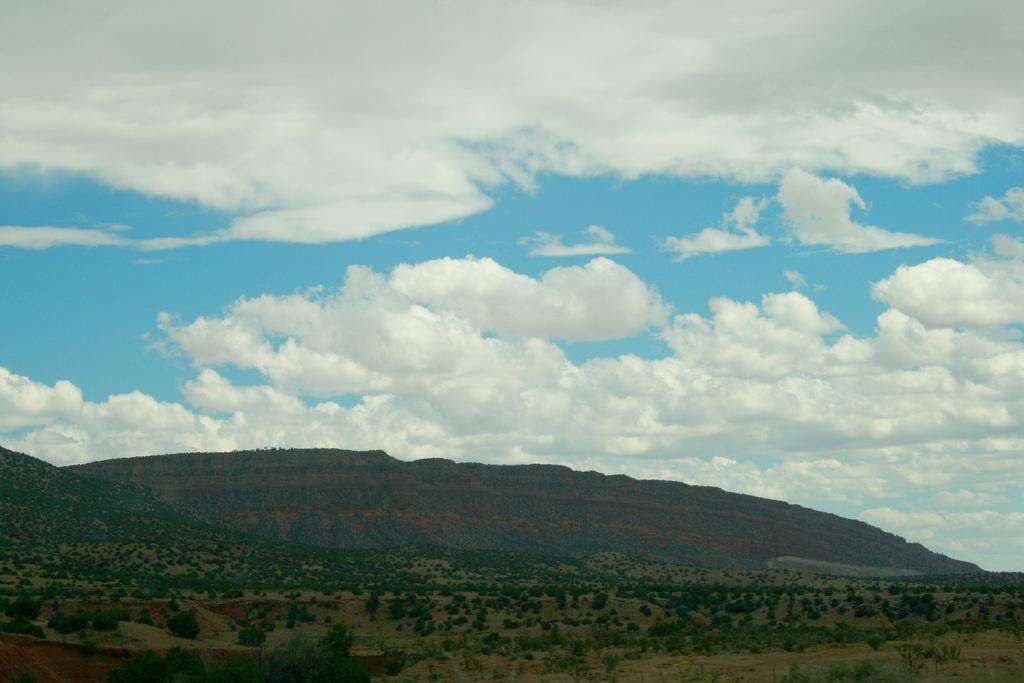What can be seen in the middle of the picture? There are trees and hills in the middle of the picture. What is visible in the sky in the background of the image? Clouds are visible in the sky in the background of the image. Where is the family having lunch in the image? There is no family or lunch present in the image; it features trees, hills, and clouds. What type of cord is being used to connect the trees in the image? There is no cord connecting the trees in the image; they are separate entities. 